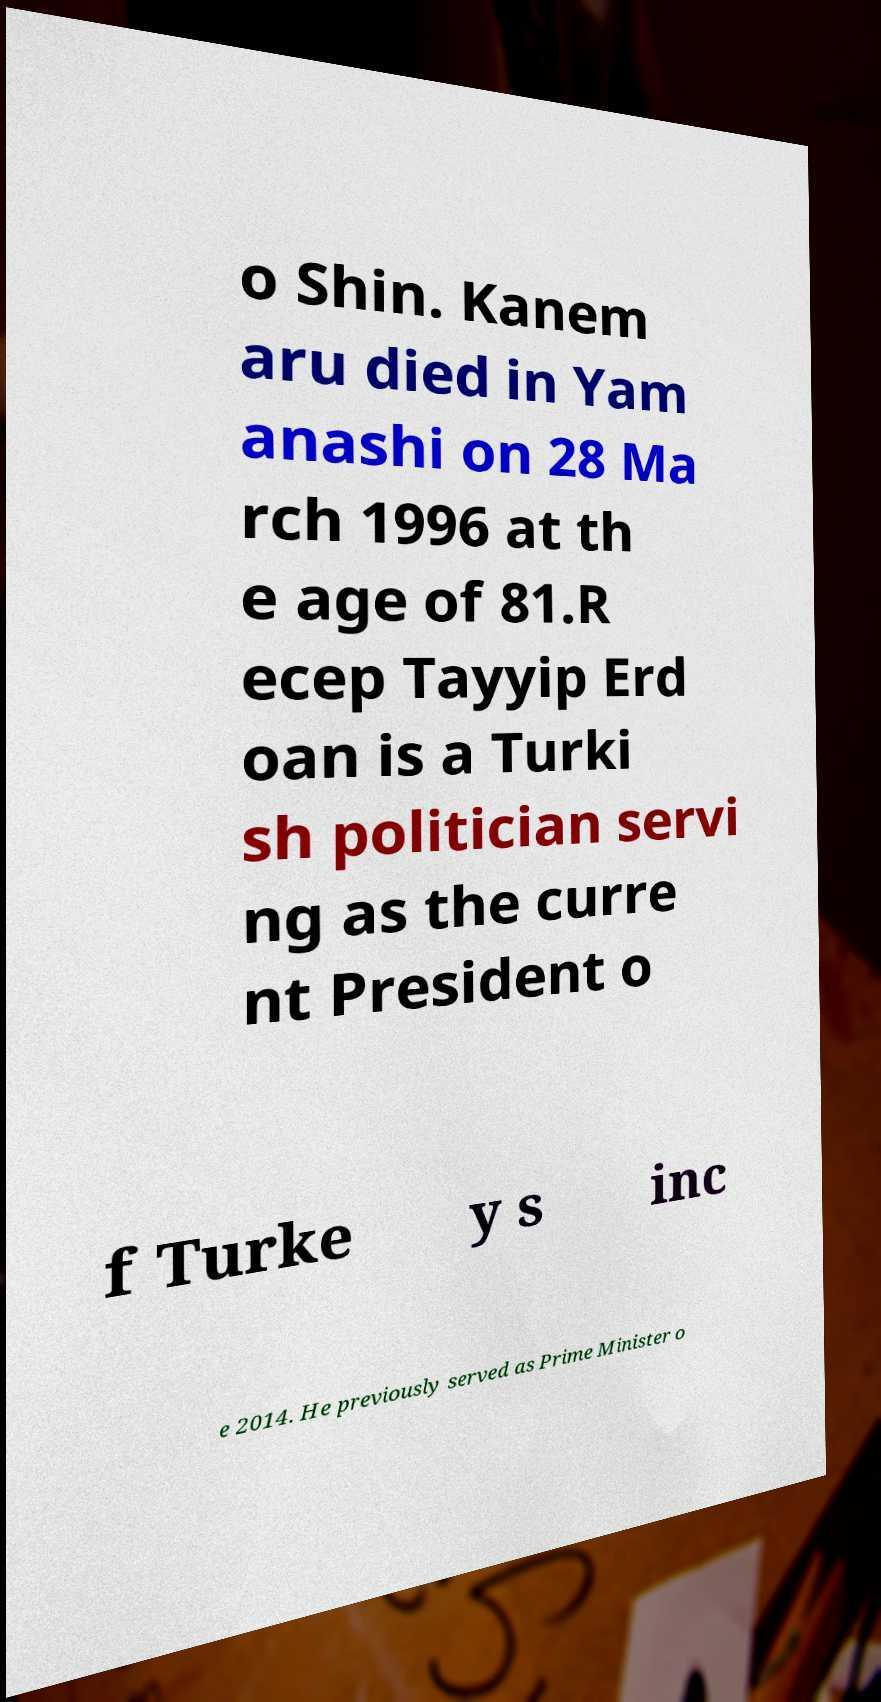What messages or text are displayed in this image? I need them in a readable, typed format. o Shin. Kanem aru died in Yam anashi on 28 Ma rch 1996 at th e age of 81.R ecep Tayyip Erd oan is a Turki sh politician servi ng as the curre nt President o f Turke y s inc e 2014. He previously served as Prime Minister o 